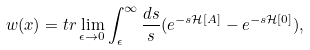Convert formula to latex. <formula><loc_0><loc_0><loc_500><loc_500>w ( x ) = t r \lim _ { \epsilon \to 0 } \int _ { \epsilon } ^ { \infty } \frac { d s } { s } ( e ^ { - s { \mathcal { H } } [ A ] } - e ^ { - s { \mathcal { H } } [ 0 ] } ) ,</formula> 